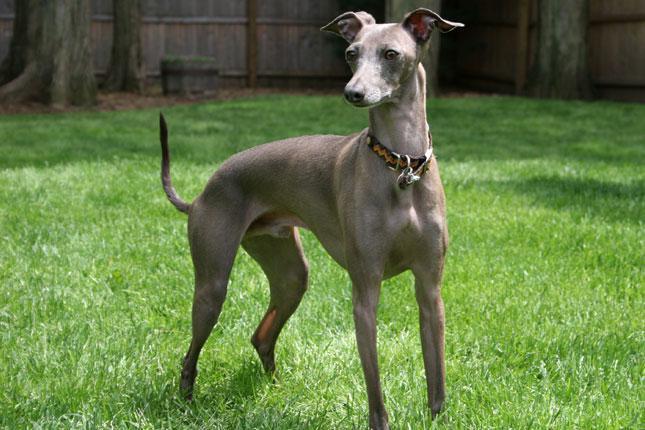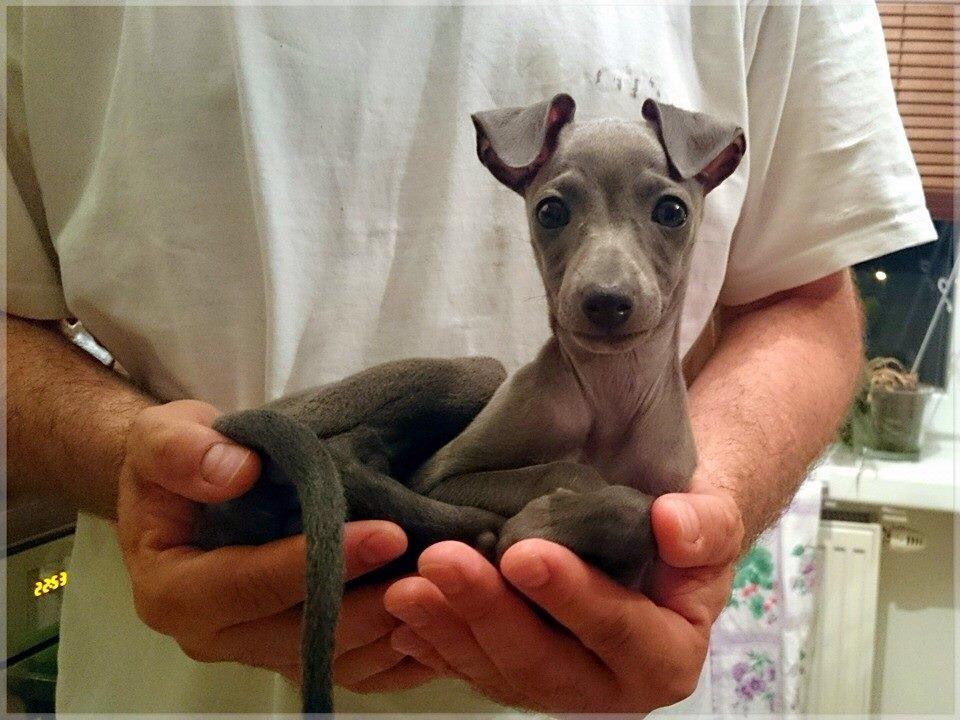The first image is the image on the left, the second image is the image on the right. Examine the images to the left and right. Is the description "There are more hound dogs in the right image than in the left." accurate? Answer yes or no. No. The first image is the image on the left, the second image is the image on the right. For the images displayed, is the sentence "One of the dogs is in green vegetation." factually correct? Answer yes or no. Yes. 